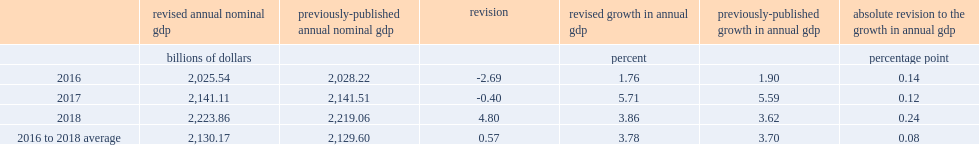With the incorporation of new benchmark data from the supply and use tables, what was the level of nominal gdp revised down in 2016? 2.69. In 2017, what was the percentage of the level of nominal gdp revised down, largely because of a downward revision of household final consumption expenditure? 0.4. In 2018, what was the level of nominal gdp revised up, resulting largely from higher household final consumption expenditure and increased governments' gross fixed capital formation? 4.8. 